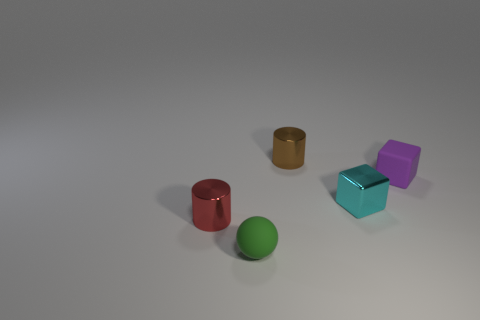Add 1 brown things. How many objects exist? 6 Subtract all balls. How many objects are left? 4 Add 3 tiny purple matte objects. How many tiny purple matte objects are left? 4 Add 5 large gray metal balls. How many large gray metal balls exist? 5 Subtract 0 green blocks. How many objects are left? 5 Subtract all large red rubber cylinders. Subtract all tiny purple rubber cubes. How many objects are left? 4 